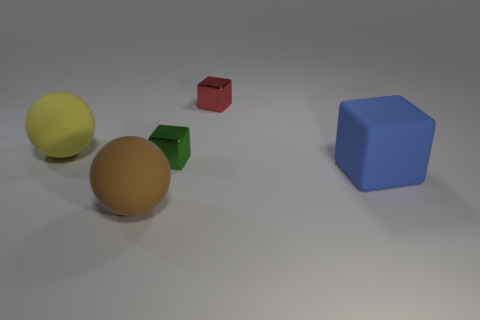Add 4 spheres. How many objects exist? 9 Subtract all spheres. How many objects are left? 3 Subtract 0 purple blocks. How many objects are left? 5 Subtract all large matte blocks. Subtract all spheres. How many objects are left? 2 Add 5 large brown objects. How many large brown objects are left? 6 Add 3 yellow cylinders. How many yellow cylinders exist? 3 